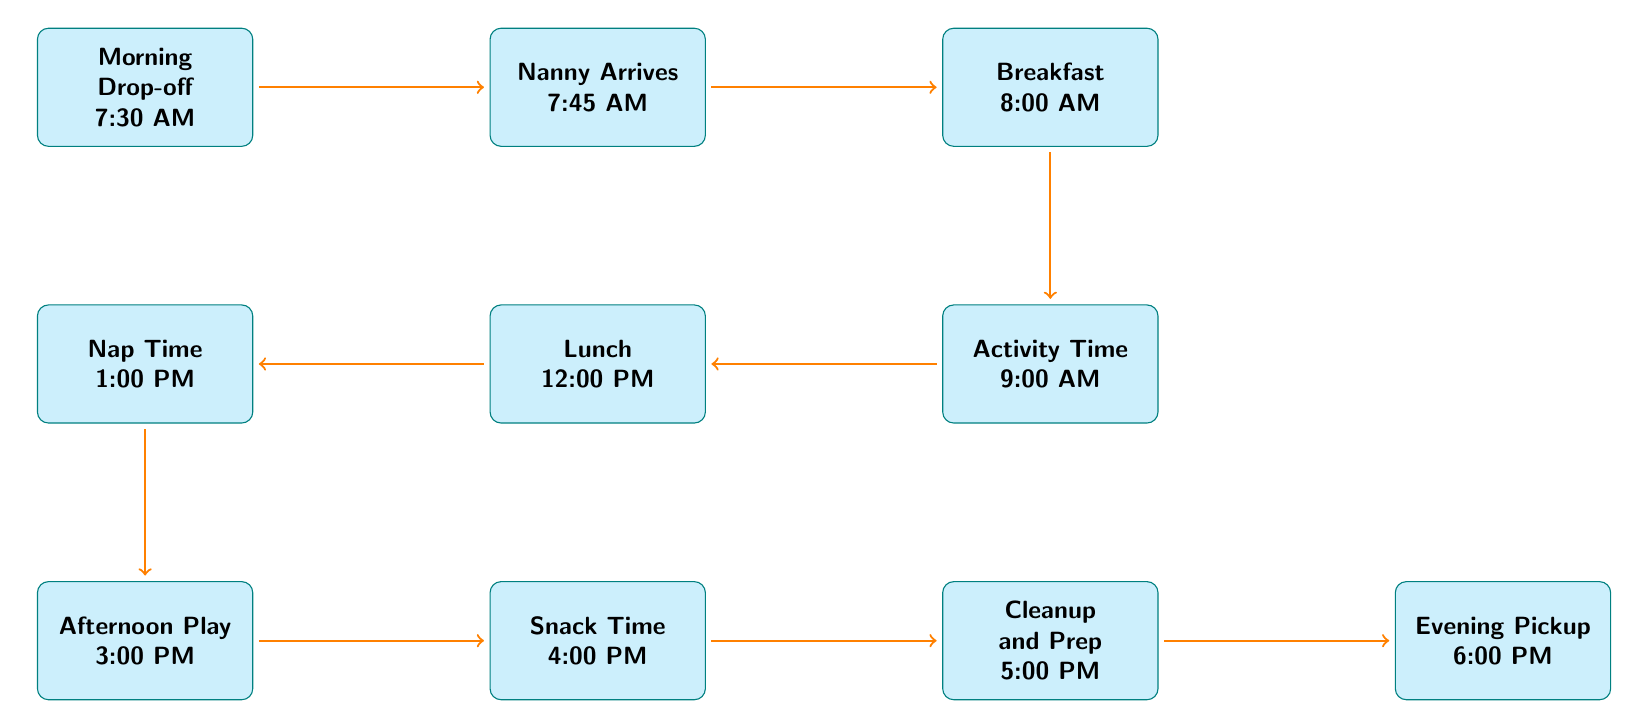What is the first activity in the schedule? The first node in the diagram is "Morning Drop-off," which is indicated as the starting point of the flow.
Answer: Morning Drop-off At what time does the Nanny arrive? The second node mentions "Nanny Arrives" and indicates the time as 7:45 AM.
Answer: 7:45 AM How many activities are scheduled between Breakfast and Nap Time? The activities between Breakfast (node 3) and Nap Time (node 6) are "Activity Time" (node 4) and "Lunch" (node 5), making a total of 2 activities.
Answer: 2 What activity immediately follows Snack Time? "Cleanup and Prep" is the next node that comes after "Snack Time" according to the flow of the diagram.
Answer: Cleanup and Prep What is the time allocated for Afternoon Play? The node labeled "Afternoon Play" specifies that this activity occurs at 3:00 PM.
Answer: 3:00 PM How many total nodes are there in the diagram? Counting all the activities from the Morning Drop-off to Evening Pickup, there are 10 nodes in total.
Answer: 10 What is the duration from Lunch to Afternoon Play? Lunch is at 12:00 PM and Afternoon Play begins at 3:00 PM. The duration between these times is 3 hours.
Answer: 3 hours What is the last activity of the day? The final node in the diagram is labeled "Evening Pickup," indicating it is the last scheduled event for the day.
Answer: Evening Pickup 